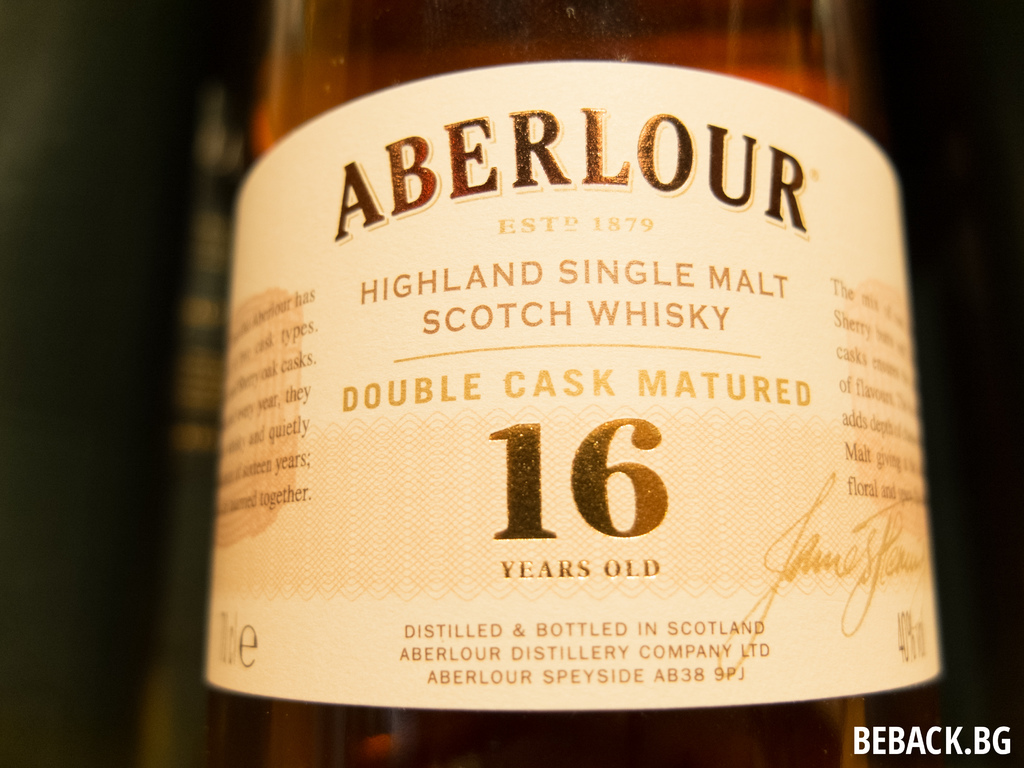What process makes Aberlour's 16-year-old whisky unique? Aberlour's 16-year-old Scotch whisky is distinctive due to its double cask maturation process, where the whisky is aged in two types of casks—traditional oak and sherry casks—which imbues it with a rich blend of flavors and a deep, complex character. How does using different casks affect the taste? The use of traditional oak casks provides the whisky with sturdy, foundational oak and vanilla notes, while the sherry casks contribute richer, sweeter flavors like dried fruits and spices. This combination creates a layered, sophisticated taste profile. 